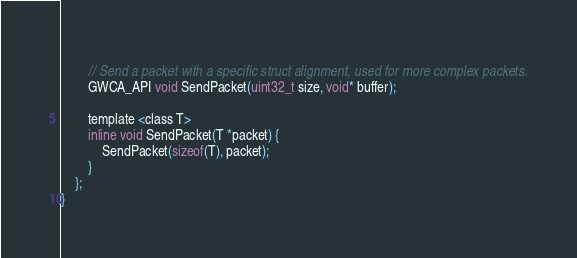<code> <loc_0><loc_0><loc_500><loc_500><_C_>        
        // Send a packet with a specific struct alignment, used for more complex packets.
        GWCA_API void SendPacket(uint32_t size, void* buffer);

        template <class T>
        inline void SendPacket(T *packet) {
            SendPacket(sizeof(T), packet);
        }
    };
}
</code> 